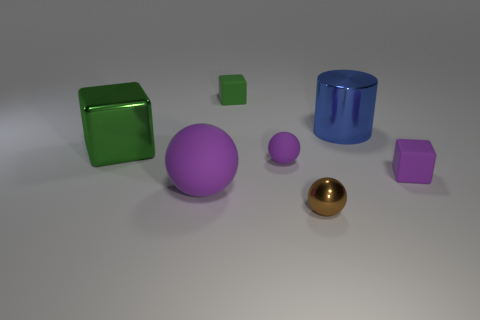Add 1 big cubes. How many objects exist? 8 Subtract all cubes. How many objects are left? 4 Add 1 tiny purple matte things. How many tiny purple matte things exist? 3 Subtract 0 gray cubes. How many objects are left? 7 Subtract all small green blocks. Subtract all big red rubber spheres. How many objects are left? 6 Add 7 tiny shiny balls. How many tiny shiny balls are left? 8 